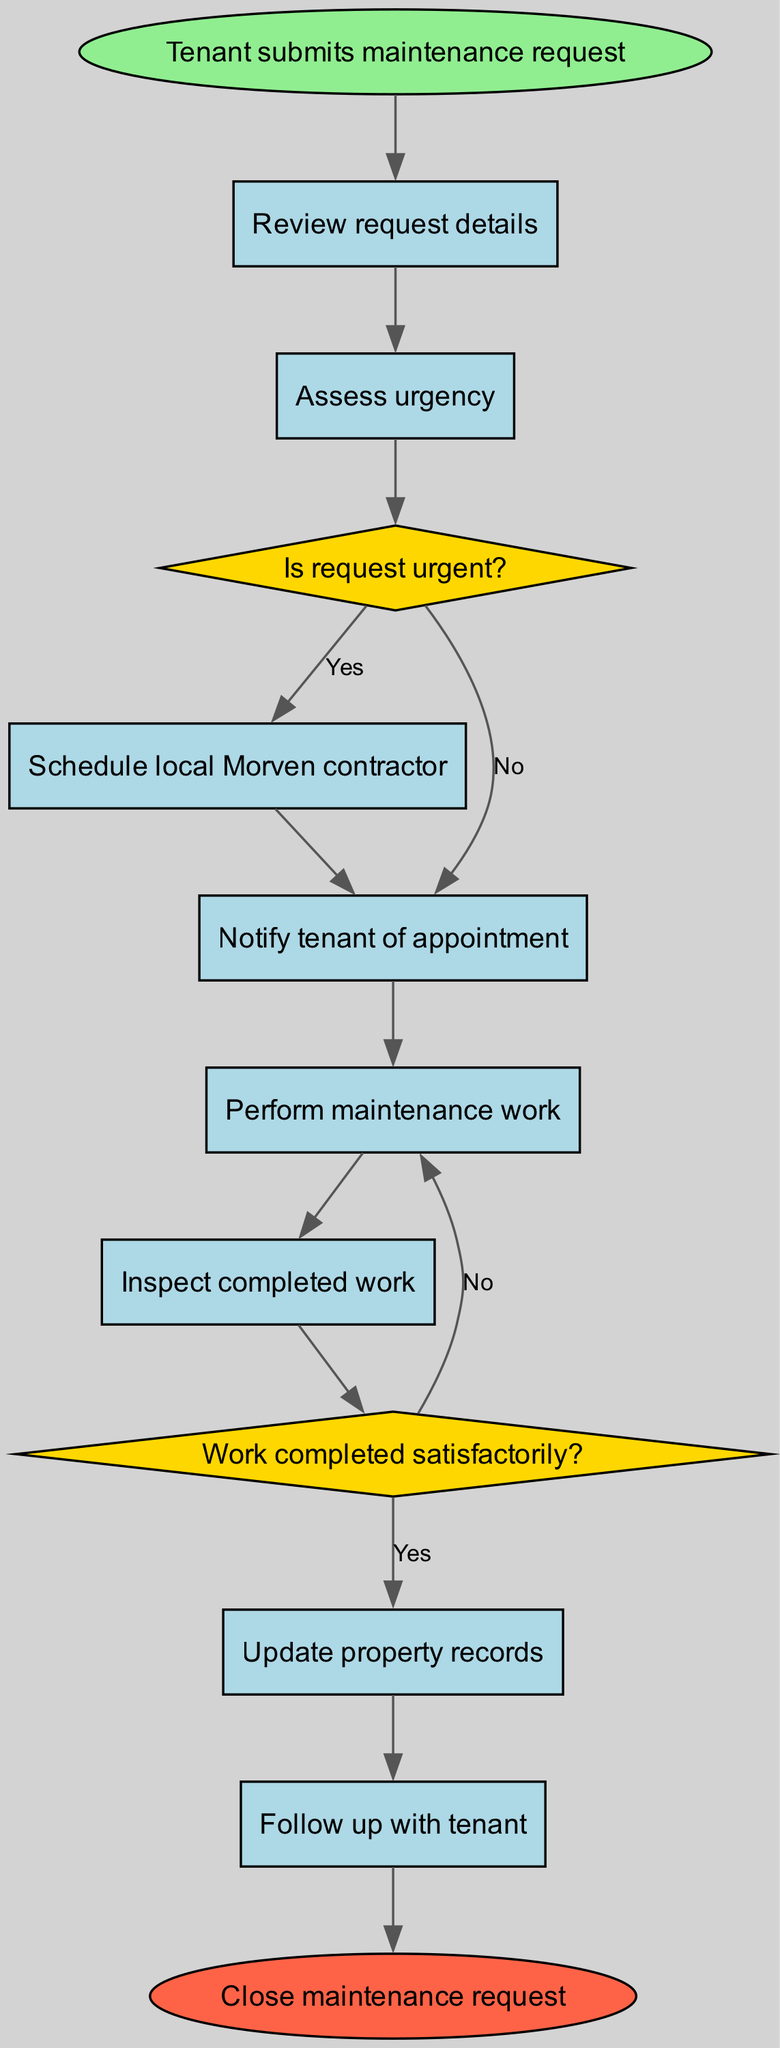What is the first step in the workflow? The first step in the workflow is represented by the start node, which indicates that "Tenant submits maintenance request" is the initial action taken in this process.
Answer: Tenant submits maintenance request How many nodes are there in the diagram? By counting all the process nodes (8), decision nodes (2), and the start and end nodes (2), the total number of nodes in the diagram is 12.
Answer: 12 What happens after the maintenance request details are reviewed? After reviewing the maintenance request details (first process node), the workflow proceeds to assess the urgency of the request as shown by the directed edge from this node to the next.
Answer: Assess urgency What is the final action in the maintenance request process? The final action, represented in the end node, states "Close maintenance request," which indicates the conclusion of the workflow after all prior steps have been completed.
Answer: Close maintenance request What decision follows assessing urgency? The decision following the urgency assessment is whether the request is urgent, indicated in the diagram as "Is request urgent?". Based on the answer, the flow will continue to different subsequent nodes.
Answer: Is request urgent? If the work is completed satisfactorily, what is the next step? If the answer to whether the work is completed satisfactorily is "Yes," the workflow indicates that it advances to the step of updating property records as shown in the directed edge from the decision node to that process node.
Answer: Update property records Which node is connected directly to the end node? According to the flowchart, the only node connected directly to the end node is "Follow up with tenant," meaning this step must be completed before the maintenance request can be closed.
Answer: Follow up with tenant What is the node that comes after notifying the tenant of an appointment? The node that follows the action of notifying the tenant of the appointment is entering the "Perform maintenance work", as shown by the edge connecting these two process nodes in the sequence.
Answer: Perform maintenance work What action occurs if the request is urgent? If the request is determined to be urgent, the workflow directs to scheduling a local Morven contractor, as evidenced by the edge that exits from the "Is request urgent?" decision node with a "Yes" label.
Answer: Schedule local Morven contractor 